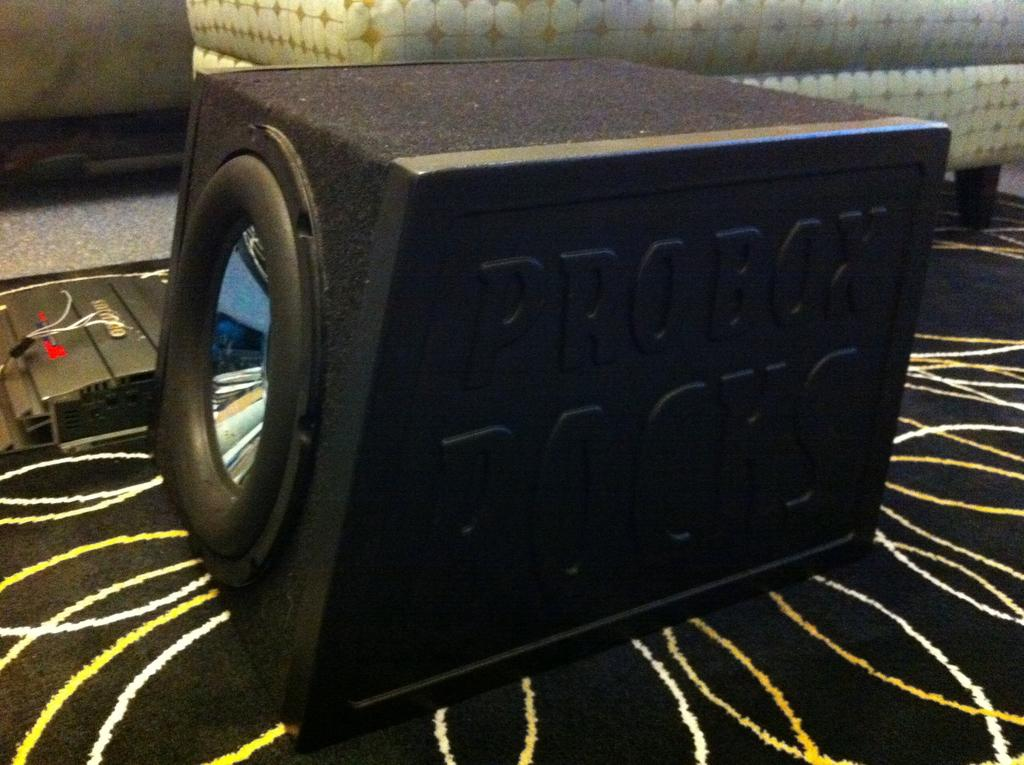What object is the main focus of the image? There is a sound box in the image. Where is the sound box located? The sound box is placed on a table. What type of neck accessory is visible on the sound box in the image? There is no neck accessory present on the sound box in the image. 